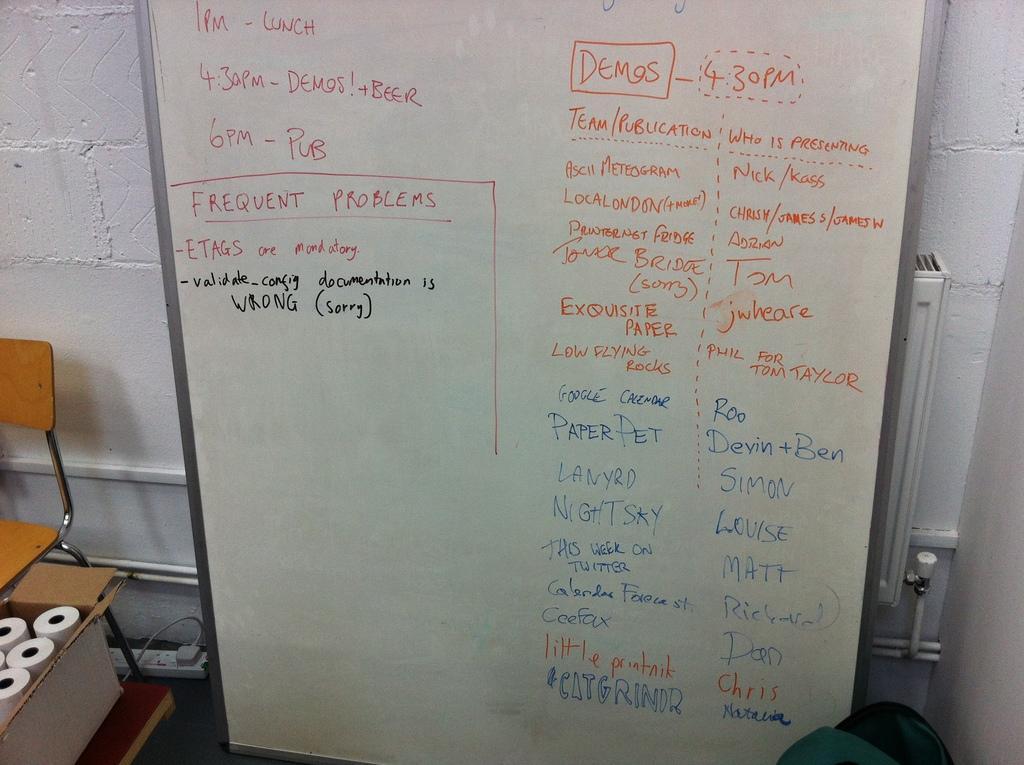Describe this image in one or two sentences. In this image, we can see a board with some text. We can see the ground and the wall with some objects. We can also see a chair and a cardboard box with some objects. We can also see an object at the bottom. 